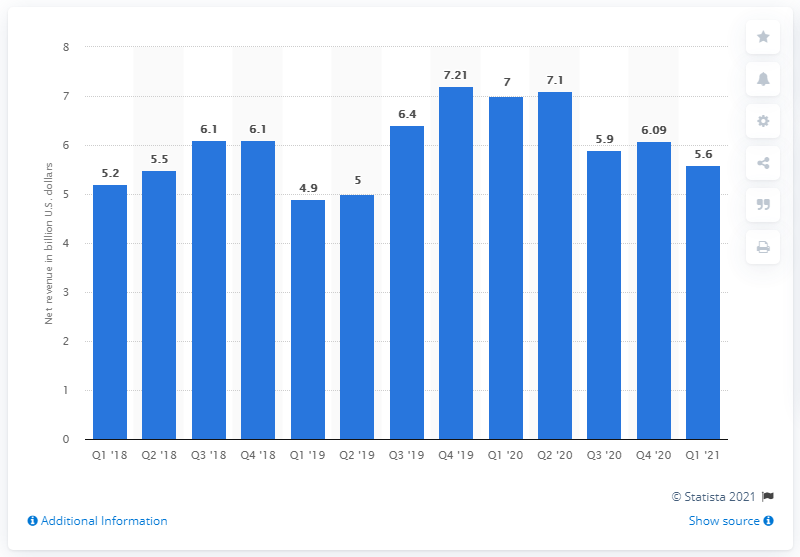Indicate a few pertinent items in this graphic. Intel's Data Center Group (DCG) revenue for the first quarter of 2021 was approximately $5.6 billion. 